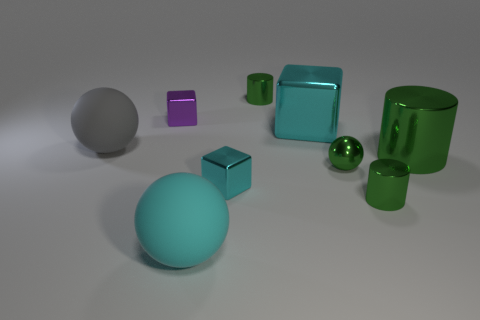Add 1 large cylinders. How many objects exist? 10 Subtract all spheres. How many objects are left? 6 Add 1 small green metallic things. How many small green metallic things exist? 4 Subtract 2 cyan cubes. How many objects are left? 7 Subtract all green metallic things. Subtract all green spheres. How many objects are left? 4 Add 7 big cylinders. How many big cylinders are left? 8 